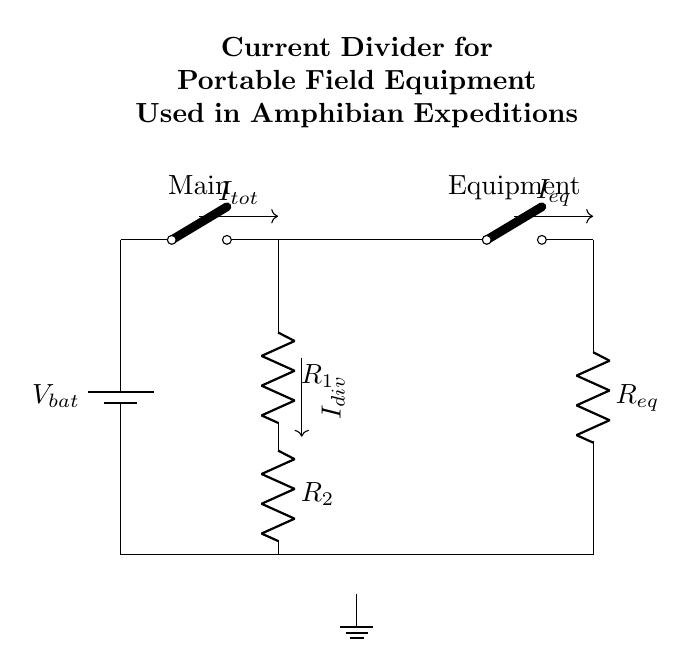What is the total current entering the circuit? The total current entering the circuit is represented by the symbol I_tot, which is shown in the diagram as the total input current from the battery before it splits into the branches.
Answer: I_tot What are the two resistances in the current divider? The two resistances in the current divider are labeled R_1 and R_2, indicated in the circuit diagram. These resistors divide the total current I_tot into I_div based on their values.
Answer: R_1 and R_2 Which component has a label indicating it is open? The component labeled as a cute open switch is marked as Main and Equipment in the circuit diagram. Both indicate that they can connect or disconnect portions of the circuit, which is crucial for managing power to the equipment.
Answer: Main and Equipment What is the purpose of using a current divider in this circuit? The purpose of using a current divider is to manage how much current flows through different branches of the circuit, ensuring that the equipment gets sufficient power while optimizing battery usage during amphibian expeditions.
Answer: To manage current flow How does the value of R_1 affect I_div compared to R_2? According to the current divider rule, if R_1 is smaller than R_2, then I_div will be larger as current will preferentially flow through the lower resistance; conversely, if R_1 is larger, I_div will be smaller due to the higher resistance influencing the division.
Answer: It inversely affects I_div What is the equivalent resistance in the equipment branch? The equipment branch contains the resistor R_eq, which represents the total resistance experienced by the current specifically for the equipment connected, shown as a single resistance in that part of the circuit.
Answer: R_eq 